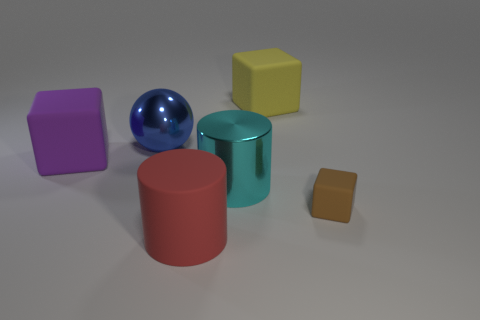Subtract all big yellow matte blocks. How many blocks are left? 2 Subtract all purple cubes. How many cubes are left? 2 Subtract all spheres. How many objects are left? 5 Add 2 purple blocks. How many objects exist? 8 Subtract all large yellow rubber objects. Subtract all small purple shiny blocks. How many objects are left? 5 Add 3 big cyan objects. How many big cyan objects are left? 4 Add 6 yellow cubes. How many yellow cubes exist? 7 Subtract 0 gray cubes. How many objects are left? 6 Subtract all yellow balls. Subtract all gray cylinders. How many balls are left? 1 Subtract all blue balls. How many red cubes are left? 0 